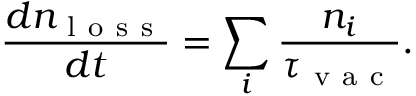<formula> <loc_0><loc_0><loc_500><loc_500>\frac { d n _ { l o s s } } { d t } = \sum _ { i } \frac { n _ { i } } { \tau _ { v a c } } .</formula> 